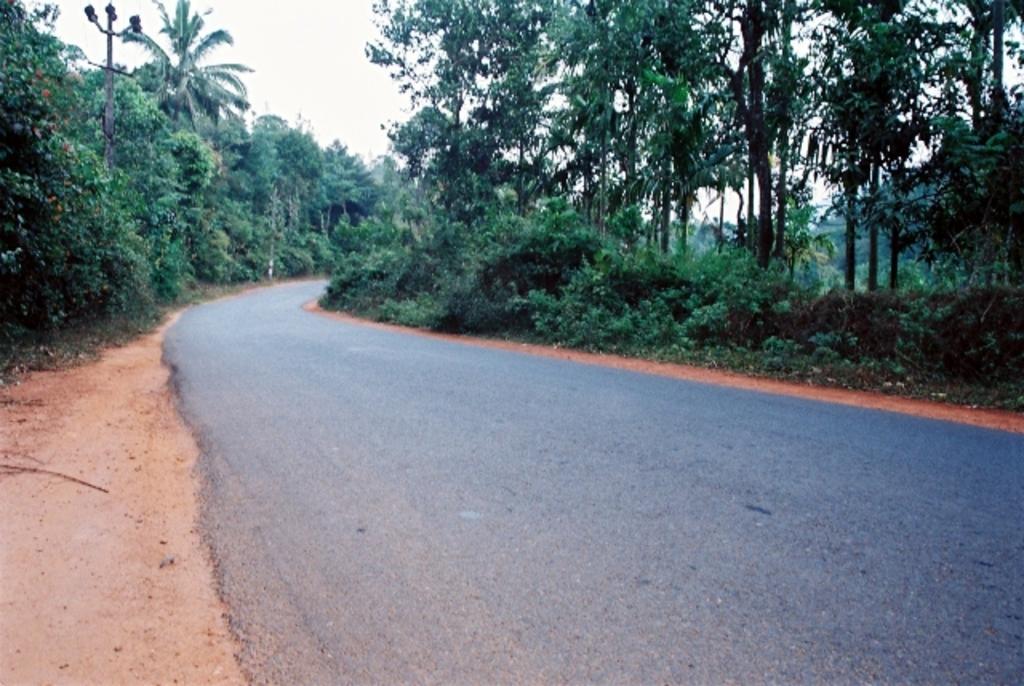Describe this image in one or two sentences. There is a road at the bottom of this image. We can see trees in the background and there is a sky at the top of this image. 